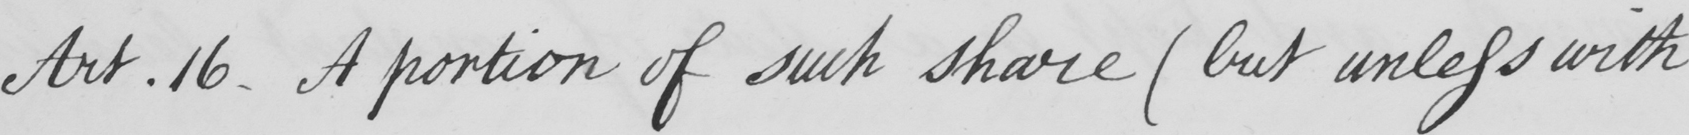Can you tell me what this handwritten text says? Art.16 . A portion of such share  ( but unless with 